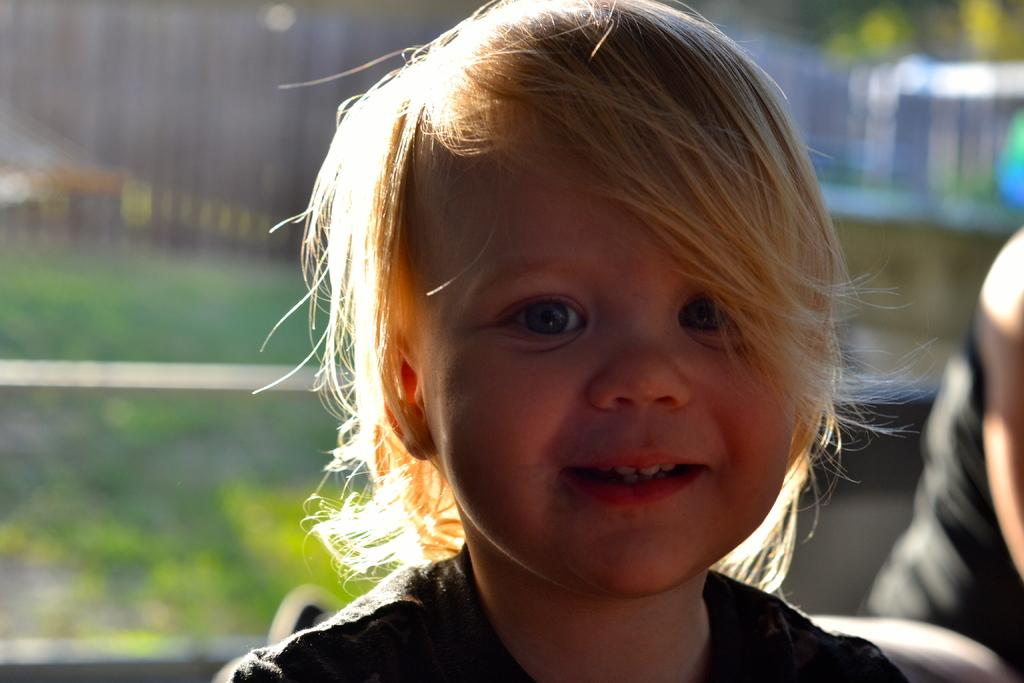What is the main subject of the image? There is a kid in the center of the image. What is the kid doing in the image? The kid is sitting. What is the kid's facial expression in the image? The kid is smiling. What can be seen in the background of the image? There is a person and a fence in the background of the image. What type of pen is the kid holding in the image? There is no pen present in the image; the kid is simply sitting and smiling. What type of sand can be seen in the image? There is no sand present in the image; it features a kid sitting and smiling, with a person and a fence in the background. 